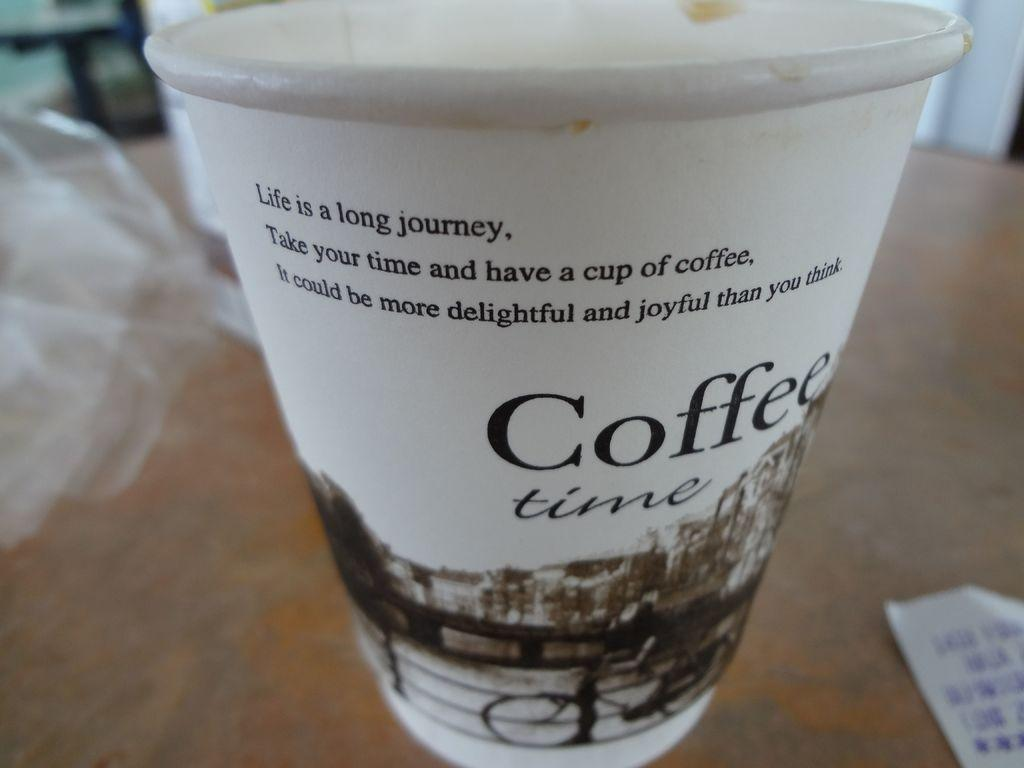What object is visible in the image? There is a cup in the image. Where is the cup located? The cup is on a table. What is written on the cup? The cup has the words "Coffee Time" written on it. What can be seen on the left side of the cup? There is a cover on the left side of the cup. What is present on the right side of the cup? There is a piece of paper on the right side of the cup. How tall is the tree growing next to the cup in the image? There is no tree present in the image; it only features a cup on a table. 